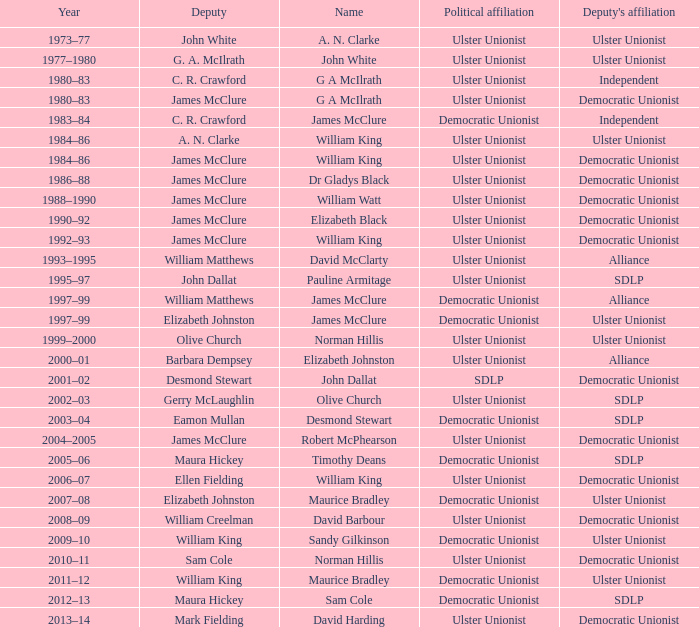Can you provide the name of the deputy who served in 1992-93? James McClure. 